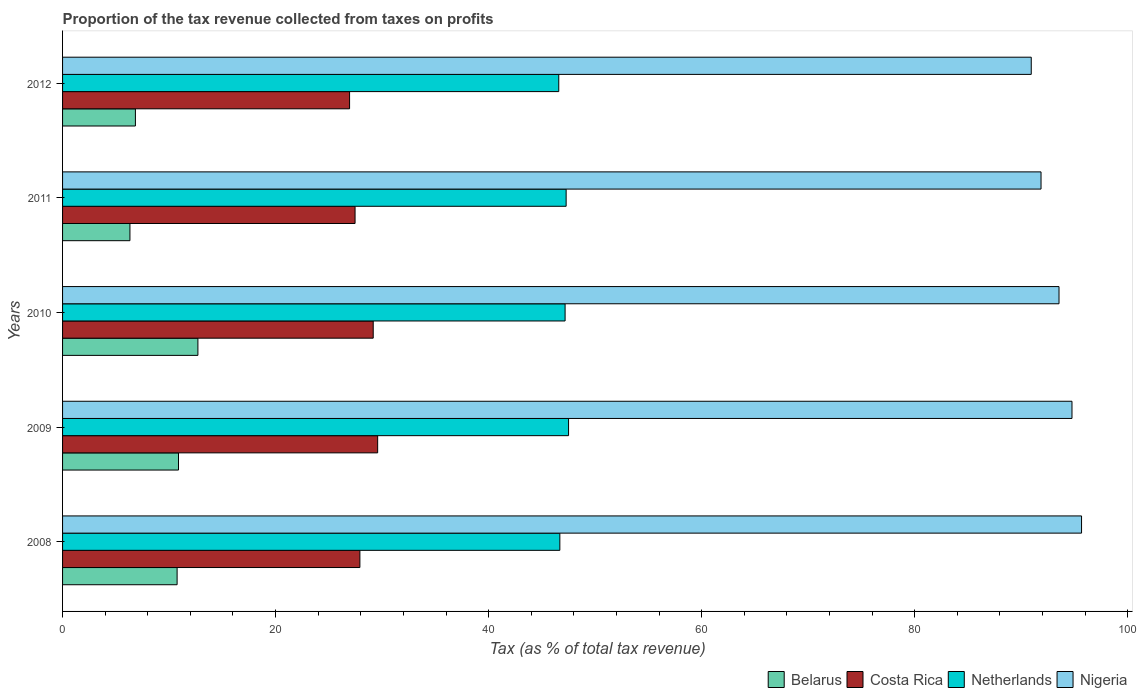Are the number of bars on each tick of the Y-axis equal?
Offer a terse response. Yes. How many bars are there on the 1st tick from the bottom?
Your answer should be very brief. 4. What is the label of the 4th group of bars from the top?
Ensure brevity in your answer.  2009. What is the proportion of the tax revenue collected in Costa Rica in 2012?
Keep it short and to the point. 26.95. Across all years, what is the maximum proportion of the tax revenue collected in Netherlands?
Ensure brevity in your answer.  47.51. Across all years, what is the minimum proportion of the tax revenue collected in Netherlands?
Offer a very short reply. 46.59. What is the total proportion of the tax revenue collected in Belarus in the graph?
Your response must be concise. 47.51. What is the difference between the proportion of the tax revenue collected in Netherlands in 2010 and that in 2011?
Offer a terse response. -0.1. What is the difference between the proportion of the tax revenue collected in Nigeria in 2010 and the proportion of the tax revenue collected in Netherlands in 2012?
Your answer should be compact. 46.97. What is the average proportion of the tax revenue collected in Costa Rica per year?
Your answer should be very brief. 28.21. In the year 2010, what is the difference between the proportion of the tax revenue collected in Belarus and proportion of the tax revenue collected in Nigeria?
Provide a short and direct response. -80.85. In how many years, is the proportion of the tax revenue collected in Belarus greater than 4 %?
Provide a succinct answer. 5. What is the ratio of the proportion of the tax revenue collected in Belarus in 2009 to that in 2011?
Your response must be concise. 1.72. Is the proportion of the tax revenue collected in Belarus in 2009 less than that in 2011?
Your response must be concise. No. What is the difference between the highest and the second highest proportion of the tax revenue collected in Belarus?
Provide a succinct answer. 1.82. What is the difference between the highest and the lowest proportion of the tax revenue collected in Costa Rica?
Keep it short and to the point. 2.64. Is the sum of the proportion of the tax revenue collected in Nigeria in 2011 and 2012 greater than the maximum proportion of the tax revenue collected in Belarus across all years?
Your answer should be very brief. Yes. Is it the case that in every year, the sum of the proportion of the tax revenue collected in Netherlands and proportion of the tax revenue collected in Costa Rica is greater than the sum of proportion of the tax revenue collected in Nigeria and proportion of the tax revenue collected in Belarus?
Give a very brief answer. No. What does the 2nd bar from the bottom in 2008 represents?
Your answer should be compact. Costa Rica. Is it the case that in every year, the sum of the proportion of the tax revenue collected in Netherlands and proportion of the tax revenue collected in Nigeria is greater than the proportion of the tax revenue collected in Costa Rica?
Ensure brevity in your answer.  Yes. Are all the bars in the graph horizontal?
Your answer should be very brief. Yes. How many years are there in the graph?
Your answer should be very brief. 5. Are the values on the major ticks of X-axis written in scientific E-notation?
Make the answer very short. No. How many legend labels are there?
Offer a terse response. 4. What is the title of the graph?
Offer a very short reply. Proportion of the tax revenue collected from taxes on profits. Does "Timor-Leste" appear as one of the legend labels in the graph?
Provide a short and direct response. No. What is the label or title of the X-axis?
Provide a short and direct response. Tax (as % of total tax revenue). What is the Tax (as % of total tax revenue) in Belarus in 2008?
Your answer should be very brief. 10.75. What is the Tax (as % of total tax revenue) of Costa Rica in 2008?
Make the answer very short. 27.91. What is the Tax (as % of total tax revenue) of Netherlands in 2008?
Your answer should be compact. 46.69. What is the Tax (as % of total tax revenue) in Nigeria in 2008?
Keep it short and to the point. 95.67. What is the Tax (as % of total tax revenue) in Belarus in 2009?
Provide a short and direct response. 10.89. What is the Tax (as % of total tax revenue) in Costa Rica in 2009?
Offer a terse response. 29.58. What is the Tax (as % of total tax revenue) of Netherlands in 2009?
Provide a succinct answer. 47.51. What is the Tax (as % of total tax revenue) in Nigeria in 2009?
Offer a very short reply. 94.77. What is the Tax (as % of total tax revenue) of Belarus in 2010?
Your response must be concise. 12.71. What is the Tax (as % of total tax revenue) of Costa Rica in 2010?
Make the answer very short. 29.17. What is the Tax (as % of total tax revenue) in Netherlands in 2010?
Your response must be concise. 47.18. What is the Tax (as % of total tax revenue) of Nigeria in 2010?
Your answer should be very brief. 93.55. What is the Tax (as % of total tax revenue) of Belarus in 2011?
Offer a terse response. 6.32. What is the Tax (as % of total tax revenue) of Costa Rica in 2011?
Make the answer very short. 27.46. What is the Tax (as % of total tax revenue) in Netherlands in 2011?
Ensure brevity in your answer.  47.28. What is the Tax (as % of total tax revenue) in Nigeria in 2011?
Ensure brevity in your answer.  91.87. What is the Tax (as % of total tax revenue) of Belarus in 2012?
Give a very brief answer. 6.84. What is the Tax (as % of total tax revenue) of Costa Rica in 2012?
Keep it short and to the point. 26.95. What is the Tax (as % of total tax revenue) of Netherlands in 2012?
Make the answer very short. 46.59. What is the Tax (as % of total tax revenue) of Nigeria in 2012?
Make the answer very short. 90.95. Across all years, what is the maximum Tax (as % of total tax revenue) in Belarus?
Offer a very short reply. 12.71. Across all years, what is the maximum Tax (as % of total tax revenue) in Costa Rica?
Provide a succinct answer. 29.58. Across all years, what is the maximum Tax (as % of total tax revenue) in Netherlands?
Offer a very short reply. 47.51. Across all years, what is the maximum Tax (as % of total tax revenue) of Nigeria?
Provide a succinct answer. 95.67. Across all years, what is the minimum Tax (as % of total tax revenue) of Belarus?
Give a very brief answer. 6.32. Across all years, what is the minimum Tax (as % of total tax revenue) of Costa Rica?
Your response must be concise. 26.95. Across all years, what is the minimum Tax (as % of total tax revenue) of Netherlands?
Provide a short and direct response. 46.59. Across all years, what is the minimum Tax (as % of total tax revenue) in Nigeria?
Keep it short and to the point. 90.95. What is the total Tax (as % of total tax revenue) in Belarus in the graph?
Offer a terse response. 47.51. What is the total Tax (as % of total tax revenue) in Costa Rica in the graph?
Offer a terse response. 141.07. What is the total Tax (as % of total tax revenue) of Netherlands in the graph?
Provide a succinct answer. 235.25. What is the total Tax (as % of total tax revenue) of Nigeria in the graph?
Offer a terse response. 466.81. What is the difference between the Tax (as % of total tax revenue) of Belarus in 2008 and that in 2009?
Make the answer very short. -0.13. What is the difference between the Tax (as % of total tax revenue) in Costa Rica in 2008 and that in 2009?
Your answer should be very brief. -1.67. What is the difference between the Tax (as % of total tax revenue) of Netherlands in 2008 and that in 2009?
Your answer should be compact. -0.82. What is the difference between the Tax (as % of total tax revenue) in Nigeria in 2008 and that in 2009?
Provide a short and direct response. 0.9. What is the difference between the Tax (as % of total tax revenue) of Belarus in 2008 and that in 2010?
Give a very brief answer. -1.95. What is the difference between the Tax (as % of total tax revenue) in Costa Rica in 2008 and that in 2010?
Offer a terse response. -1.25. What is the difference between the Tax (as % of total tax revenue) of Netherlands in 2008 and that in 2010?
Make the answer very short. -0.49. What is the difference between the Tax (as % of total tax revenue) of Nigeria in 2008 and that in 2010?
Your answer should be very brief. 2.12. What is the difference between the Tax (as % of total tax revenue) in Belarus in 2008 and that in 2011?
Make the answer very short. 4.43. What is the difference between the Tax (as % of total tax revenue) of Costa Rica in 2008 and that in 2011?
Your response must be concise. 0.45. What is the difference between the Tax (as % of total tax revenue) in Netherlands in 2008 and that in 2011?
Ensure brevity in your answer.  -0.59. What is the difference between the Tax (as % of total tax revenue) of Nigeria in 2008 and that in 2011?
Give a very brief answer. 3.8. What is the difference between the Tax (as % of total tax revenue) of Belarus in 2008 and that in 2012?
Ensure brevity in your answer.  3.91. What is the difference between the Tax (as % of total tax revenue) in Costa Rica in 2008 and that in 2012?
Offer a terse response. 0.97. What is the difference between the Tax (as % of total tax revenue) in Netherlands in 2008 and that in 2012?
Ensure brevity in your answer.  0.1. What is the difference between the Tax (as % of total tax revenue) of Nigeria in 2008 and that in 2012?
Provide a succinct answer. 4.72. What is the difference between the Tax (as % of total tax revenue) of Belarus in 2009 and that in 2010?
Your answer should be compact. -1.82. What is the difference between the Tax (as % of total tax revenue) in Costa Rica in 2009 and that in 2010?
Make the answer very short. 0.42. What is the difference between the Tax (as % of total tax revenue) of Netherlands in 2009 and that in 2010?
Offer a terse response. 0.33. What is the difference between the Tax (as % of total tax revenue) of Nigeria in 2009 and that in 2010?
Provide a short and direct response. 1.22. What is the difference between the Tax (as % of total tax revenue) of Belarus in 2009 and that in 2011?
Offer a terse response. 4.56. What is the difference between the Tax (as % of total tax revenue) of Costa Rica in 2009 and that in 2011?
Offer a very short reply. 2.12. What is the difference between the Tax (as % of total tax revenue) in Netherlands in 2009 and that in 2011?
Provide a succinct answer. 0.23. What is the difference between the Tax (as % of total tax revenue) of Nigeria in 2009 and that in 2011?
Give a very brief answer. 2.91. What is the difference between the Tax (as % of total tax revenue) in Belarus in 2009 and that in 2012?
Keep it short and to the point. 4.05. What is the difference between the Tax (as % of total tax revenue) in Costa Rica in 2009 and that in 2012?
Offer a very short reply. 2.64. What is the difference between the Tax (as % of total tax revenue) in Netherlands in 2009 and that in 2012?
Give a very brief answer. 0.92. What is the difference between the Tax (as % of total tax revenue) in Nigeria in 2009 and that in 2012?
Offer a very short reply. 3.82. What is the difference between the Tax (as % of total tax revenue) of Belarus in 2010 and that in 2011?
Your answer should be compact. 6.38. What is the difference between the Tax (as % of total tax revenue) in Costa Rica in 2010 and that in 2011?
Provide a succinct answer. 1.7. What is the difference between the Tax (as % of total tax revenue) of Netherlands in 2010 and that in 2011?
Your answer should be very brief. -0.1. What is the difference between the Tax (as % of total tax revenue) of Nigeria in 2010 and that in 2011?
Keep it short and to the point. 1.69. What is the difference between the Tax (as % of total tax revenue) of Belarus in 2010 and that in 2012?
Give a very brief answer. 5.87. What is the difference between the Tax (as % of total tax revenue) in Costa Rica in 2010 and that in 2012?
Make the answer very short. 2.22. What is the difference between the Tax (as % of total tax revenue) in Netherlands in 2010 and that in 2012?
Your answer should be compact. 0.59. What is the difference between the Tax (as % of total tax revenue) of Nigeria in 2010 and that in 2012?
Provide a short and direct response. 2.61. What is the difference between the Tax (as % of total tax revenue) in Belarus in 2011 and that in 2012?
Offer a very short reply. -0.51. What is the difference between the Tax (as % of total tax revenue) of Costa Rica in 2011 and that in 2012?
Your answer should be very brief. 0.52. What is the difference between the Tax (as % of total tax revenue) of Netherlands in 2011 and that in 2012?
Keep it short and to the point. 0.69. What is the difference between the Tax (as % of total tax revenue) in Nigeria in 2011 and that in 2012?
Offer a very short reply. 0.92. What is the difference between the Tax (as % of total tax revenue) in Belarus in 2008 and the Tax (as % of total tax revenue) in Costa Rica in 2009?
Offer a very short reply. -18.83. What is the difference between the Tax (as % of total tax revenue) in Belarus in 2008 and the Tax (as % of total tax revenue) in Netherlands in 2009?
Keep it short and to the point. -36.75. What is the difference between the Tax (as % of total tax revenue) in Belarus in 2008 and the Tax (as % of total tax revenue) in Nigeria in 2009?
Ensure brevity in your answer.  -84.02. What is the difference between the Tax (as % of total tax revenue) in Costa Rica in 2008 and the Tax (as % of total tax revenue) in Netherlands in 2009?
Give a very brief answer. -19.59. What is the difference between the Tax (as % of total tax revenue) of Costa Rica in 2008 and the Tax (as % of total tax revenue) of Nigeria in 2009?
Your answer should be very brief. -66.86. What is the difference between the Tax (as % of total tax revenue) of Netherlands in 2008 and the Tax (as % of total tax revenue) of Nigeria in 2009?
Your answer should be very brief. -48.08. What is the difference between the Tax (as % of total tax revenue) in Belarus in 2008 and the Tax (as % of total tax revenue) in Costa Rica in 2010?
Your answer should be very brief. -18.41. What is the difference between the Tax (as % of total tax revenue) in Belarus in 2008 and the Tax (as % of total tax revenue) in Netherlands in 2010?
Provide a succinct answer. -36.43. What is the difference between the Tax (as % of total tax revenue) of Belarus in 2008 and the Tax (as % of total tax revenue) of Nigeria in 2010?
Give a very brief answer. -82.8. What is the difference between the Tax (as % of total tax revenue) in Costa Rica in 2008 and the Tax (as % of total tax revenue) in Netherlands in 2010?
Your response must be concise. -19.27. What is the difference between the Tax (as % of total tax revenue) in Costa Rica in 2008 and the Tax (as % of total tax revenue) in Nigeria in 2010?
Your answer should be very brief. -65.64. What is the difference between the Tax (as % of total tax revenue) of Netherlands in 2008 and the Tax (as % of total tax revenue) of Nigeria in 2010?
Keep it short and to the point. -46.87. What is the difference between the Tax (as % of total tax revenue) of Belarus in 2008 and the Tax (as % of total tax revenue) of Costa Rica in 2011?
Your answer should be very brief. -16.71. What is the difference between the Tax (as % of total tax revenue) of Belarus in 2008 and the Tax (as % of total tax revenue) of Netherlands in 2011?
Give a very brief answer. -36.53. What is the difference between the Tax (as % of total tax revenue) of Belarus in 2008 and the Tax (as % of total tax revenue) of Nigeria in 2011?
Offer a very short reply. -81.11. What is the difference between the Tax (as % of total tax revenue) in Costa Rica in 2008 and the Tax (as % of total tax revenue) in Netherlands in 2011?
Keep it short and to the point. -19.36. What is the difference between the Tax (as % of total tax revenue) of Costa Rica in 2008 and the Tax (as % of total tax revenue) of Nigeria in 2011?
Provide a succinct answer. -63.95. What is the difference between the Tax (as % of total tax revenue) in Netherlands in 2008 and the Tax (as % of total tax revenue) in Nigeria in 2011?
Keep it short and to the point. -45.18. What is the difference between the Tax (as % of total tax revenue) of Belarus in 2008 and the Tax (as % of total tax revenue) of Costa Rica in 2012?
Offer a terse response. -16.19. What is the difference between the Tax (as % of total tax revenue) of Belarus in 2008 and the Tax (as % of total tax revenue) of Netherlands in 2012?
Make the answer very short. -35.83. What is the difference between the Tax (as % of total tax revenue) of Belarus in 2008 and the Tax (as % of total tax revenue) of Nigeria in 2012?
Your answer should be very brief. -80.19. What is the difference between the Tax (as % of total tax revenue) of Costa Rica in 2008 and the Tax (as % of total tax revenue) of Netherlands in 2012?
Your answer should be compact. -18.67. What is the difference between the Tax (as % of total tax revenue) of Costa Rica in 2008 and the Tax (as % of total tax revenue) of Nigeria in 2012?
Your answer should be very brief. -63.03. What is the difference between the Tax (as % of total tax revenue) in Netherlands in 2008 and the Tax (as % of total tax revenue) in Nigeria in 2012?
Your answer should be very brief. -44.26. What is the difference between the Tax (as % of total tax revenue) in Belarus in 2009 and the Tax (as % of total tax revenue) in Costa Rica in 2010?
Provide a short and direct response. -18.28. What is the difference between the Tax (as % of total tax revenue) in Belarus in 2009 and the Tax (as % of total tax revenue) in Netherlands in 2010?
Ensure brevity in your answer.  -36.3. What is the difference between the Tax (as % of total tax revenue) in Belarus in 2009 and the Tax (as % of total tax revenue) in Nigeria in 2010?
Provide a succinct answer. -82.67. What is the difference between the Tax (as % of total tax revenue) of Costa Rica in 2009 and the Tax (as % of total tax revenue) of Netherlands in 2010?
Provide a succinct answer. -17.6. What is the difference between the Tax (as % of total tax revenue) in Costa Rica in 2009 and the Tax (as % of total tax revenue) in Nigeria in 2010?
Provide a short and direct response. -63.97. What is the difference between the Tax (as % of total tax revenue) in Netherlands in 2009 and the Tax (as % of total tax revenue) in Nigeria in 2010?
Your response must be concise. -46.05. What is the difference between the Tax (as % of total tax revenue) of Belarus in 2009 and the Tax (as % of total tax revenue) of Costa Rica in 2011?
Offer a terse response. -16.58. What is the difference between the Tax (as % of total tax revenue) in Belarus in 2009 and the Tax (as % of total tax revenue) in Netherlands in 2011?
Your answer should be compact. -36.39. What is the difference between the Tax (as % of total tax revenue) in Belarus in 2009 and the Tax (as % of total tax revenue) in Nigeria in 2011?
Your response must be concise. -80.98. What is the difference between the Tax (as % of total tax revenue) in Costa Rica in 2009 and the Tax (as % of total tax revenue) in Netherlands in 2011?
Ensure brevity in your answer.  -17.7. What is the difference between the Tax (as % of total tax revenue) of Costa Rica in 2009 and the Tax (as % of total tax revenue) of Nigeria in 2011?
Offer a terse response. -62.28. What is the difference between the Tax (as % of total tax revenue) of Netherlands in 2009 and the Tax (as % of total tax revenue) of Nigeria in 2011?
Your answer should be very brief. -44.36. What is the difference between the Tax (as % of total tax revenue) in Belarus in 2009 and the Tax (as % of total tax revenue) in Costa Rica in 2012?
Your answer should be very brief. -16.06. What is the difference between the Tax (as % of total tax revenue) of Belarus in 2009 and the Tax (as % of total tax revenue) of Netherlands in 2012?
Make the answer very short. -35.7. What is the difference between the Tax (as % of total tax revenue) of Belarus in 2009 and the Tax (as % of total tax revenue) of Nigeria in 2012?
Your response must be concise. -80.06. What is the difference between the Tax (as % of total tax revenue) of Costa Rica in 2009 and the Tax (as % of total tax revenue) of Netherlands in 2012?
Offer a terse response. -17. What is the difference between the Tax (as % of total tax revenue) of Costa Rica in 2009 and the Tax (as % of total tax revenue) of Nigeria in 2012?
Your answer should be compact. -61.37. What is the difference between the Tax (as % of total tax revenue) in Netherlands in 2009 and the Tax (as % of total tax revenue) in Nigeria in 2012?
Your answer should be compact. -43.44. What is the difference between the Tax (as % of total tax revenue) of Belarus in 2010 and the Tax (as % of total tax revenue) of Costa Rica in 2011?
Your response must be concise. -14.76. What is the difference between the Tax (as % of total tax revenue) of Belarus in 2010 and the Tax (as % of total tax revenue) of Netherlands in 2011?
Your answer should be compact. -34.57. What is the difference between the Tax (as % of total tax revenue) of Belarus in 2010 and the Tax (as % of total tax revenue) of Nigeria in 2011?
Your answer should be very brief. -79.16. What is the difference between the Tax (as % of total tax revenue) of Costa Rica in 2010 and the Tax (as % of total tax revenue) of Netherlands in 2011?
Your response must be concise. -18.11. What is the difference between the Tax (as % of total tax revenue) in Costa Rica in 2010 and the Tax (as % of total tax revenue) in Nigeria in 2011?
Offer a very short reply. -62.7. What is the difference between the Tax (as % of total tax revenue) of Netherlands in 2010 and the Tax (as % of total tax revenue) of Nigeria in 2011?
Keep it short and to the point. -44.68. What is the difference between the Tax (as % of total tax revenue) of Belarus in 2010 and the Tax (as % of total tax revenue) of Costa Rica in 2012?
Your answer should be compact. -14.24. What is the difference between the Tax (as % of total tax revenue) in Belarus in 2010 and the Tax (as % of total tax revenue) in Netherlands in 2012?
Your answer should be very brief. -33.88. What is the difference between the Tax (as % of total tax revenue) in Belarus in 2010 and the Tax (as % of total tax revenue) in Nigeria in 2012?
Provide a succinct answer. -78.24. What is the difference between the Tax (as % of total tax revenue) of Costa Rica in 2010 and the Tax (as % of total tax revenue) of Netherlands in 2012?
Your answer should be very brief. -17.42. What is the difference between the Tax (as % of total tax revenue) of Costa Rica in 2010 and the Tax (as % of total tax revenue) of Nigeria in 2012?
Provide a short and direct response. -61.78. What is the difference between the Tax (as % of total tax revenue) in Netherlands in 2010 and the Tax (as % of total tax revenue) in Nigeria in 2012?
Make the answer very short. -43.77. What is the difference between the Tax (as % of total tax revenue) in Belarus in 2011 and the Tax (as % of total tax revenue) in Costa Rica in 2012?
Make the answer very short. -20.62. What is the difference between the Tax (as % of total tax revenue) in Belarus in 2011 and the Tax (as % of total tax revenue) in Netherlands in 2012?
Provide a short and direct response. -40.26. What is the difference between the Tax (as % of total tax revenue) of Belarus in 2011 and the Tax (as % of total tax revenue) of Nigeria in 2012?
Offer a terse response. -84.62. What is the difference between the Tax (as % of total tax revenue) of Costa Rica in 2011 and the Tax (as % of total tax revenue) of Netherlands in 2012?
Your response must be concise. -19.13. What is the difference between the Tax (as % of total tax revenue) of Costa Rica in 2011 and the Tax (as % of total tax revenue) of Nigeria in 2012?
Provide a succinct answer. -63.49. What is the difference between the Tax (as % of total tax revenue) of Netherlands in 2011 and the Tax (as % of total tax revenue) of Nigeria in 2012?
Make the answer very short. -43.67. What is the average Tax (as % of total tax revenue) in Belarus per year?
Keep it short and to the point. 9.5. What is the average Tax (as % of total tax revenue) in Costa Rica per year?
Offer a very short reply. 28.21. What is the average Tax (as % of total tax revenue) in Netherlands per year?
Keep it short and to the point. 47.05. What is the average Tax (as % of total tax revenue) in Nigeria per year?
Your response must be concise. 93.36. In the year 2008, what is the difference between the Tax (as % of total tax revenue) of Belarus and Tax (as % of total tax revenue) of Costa Rica?
Give a very brief answer. -17.16. In the year 2008, what is the difference between the Tax (as % of total tax revenue) in Belarus and Tax (as % of total tax revenue) in Netherlands?
Your response must be concise. -35.93. In the year 2008, what is the difference between the Tax (as % of total tax revenue) of Belarus and Tax (as % of total tax revenue) of Nigeria?
Your answer should be compact. -84.92. In the year 2008, what is the difference between the Tax (as % of total tax revenue) in Costa Rica and Tax (as % of total tax revenue) in Netherlands?
Your response must be concise. -18.77. In the year 2008, what is the difference between the Tax (as % of total tax revenue) of Costa Rica and Tax (as % of total tax revenue) of Nigeria?
Make the answer very short. -67.76. In the year 2008, what is the difference between the Tax (as % of total tax revenue) of Netherlands and Tax (as % of total tax revenue) of Nigeria?
Your answer should be compact. -48.98. In the year 2009, what is the difference between the Tax (as % of total tax revenue) in Belarus and Tax (as % of total tax revenue) in Costa Rica?
Provide a succinct answer. -18.7. In the year 2009, what is the difference between the Tax (as % of total tax revenue) of Belarus and Tax (as % of total tax revenue) of Netherlands?
Make the answer very short. -36.62. In the year 2009, what is the difference between the Tax (as % of total tax revenue) in Belarus and Tax (as % of total tax revenue) in Nigeria?
Your answer should be compact. -83.89. In the year 2009, what is the difference between the Tax (as % of total tax revenue) in Costa Rica and Tax (as % of total tax revenue) in Netherlands?
Keep it short and to the point. -17.92. In the year 2009, what is the difference between the Tax (as % of total tax revenue) in Costa Rica and Tax (as % of total tax revenue) in Nigeria?
Your answer should be very brief. -65.19. In the year 2009, what is the difference between the Tax (as % of total tax revenue) of Netherlands and Tax (as % of total tax revenue) of Nigeria?
Your answer should be very brief. -47.26. In the year 2010, what is the difference between the Tax (as % of total tax revenue) of Belarus and Tax (as % of total tax revenue) of Costa Rica?
Your answer should be very brief. -16.46. In the year 2010, what is the difference between the Tax (as % of total tax revenue) in Belarus and Tax (as % of total tax revenue) in Netherlands?
Ensure brevity in your answer.  -34.48. In the year 2010, what is the difference between the Tax (as % of total tax revenue) of Belarus and Tax (as % of total tax revenue) of Nigeria?
Your answer should be very brief. -80.85. In the year 2010, what is the difference between the Tax (as % of total tax revenue) in Costa Rica and Tax (as % of total tax revenue) in Netherlands?
Your answer should be compact. -18.02. In the year 2010, what is the difference between the Tax (as % of total tax revenue) of Costa Rica and Tax (as % of total tax revenue) of Nigeria?
Your response must be concise. -64.39. In the year 2010, what is the difference between the Tax (as % of total tax revenue) in Netherlands and Tax (as % of total tax revenue) in Nigeria?
Ensure brevity in your answer.  -46.37. In the year 2011, what is the difference between the Tax (as % of total tax revenue) of Belarus and Tax (as % of total tax revenue) of Costa Rica?
Provide a short and direct response. -21.14. In the year 2011, what is the difference between the Tax (as % of total tax revenue) in Belarus and Tax (as % of total tax revenue) in Netherlands?
Provide a succinct answer. -40.95. In the year 2011, what is the difference between the Tax (as % of total tax revenue) in Belarus and Tax (as % of total tax revenue) in Nigeria?
Your response must be concise. -85.54. In the year 2011, what is the difference between the Tax (as % of total tax revenue) of Costa Rica and Tax (as % of total tax revenue) of Netherlands?
Offer a very short reply. -19.82. In the year 2011, what is the difference between the Tax (as % of total tax revenue) of Costa Rica and Tax (as % of total tax revenue) of Nigeria?
Your response must be concise. -64.4. In the year 2011, what is the difference between the Tax (as % of total tax revenue) in Netherlands and Tax (as % of total tax revenue) in Nigeria?
Offer a very short reply. -44.59. In the year 2012, what is the difference between the Tax (as % of total tax revenue) of Belarus and Tax (as % of total tax revenue) of Costa Rica?
Offer a terse response. -20.11. In the year 2012, what is the difference between the Tax (as % of total tax revenue) of Belarus and Tax (as % of total tax revenue) of Netherlands?
Provide a short and direct response. -39.75. In the year 2012, what is the difference between the Tax (as % of total tax revenue) of Belarus and Tax (as % of total tax revenue) of Nigeria?
Your response must be concise. -84.11. In the year 2012, what is the difference between the Tax (as % of total tax revenue) of Costa Rica and Tax (as % of total tax revenue) of Netherlands?
Provide a succinct answer. -19.64. In the year 2012, what is the difference between the Tax (as % of total tax revenue) in Costa Rica and Tax (as % of total tax revenue) in Nigeria?
Offer a very short reply. -64. In the year 2012, what is the difference between the Tax (as % of total tax revenue) of Netherlands and Tax (as % of total tax revenue) of Nigeria?
Provide a succinct answer. -44.36. What is the ratio of the Tax (as % of total tax revenue) in Belarus in 2008 to that in 2009?
Ensure brevity in your answer.  0.99. What is the ratio of the Tax (as % of total tax revenue) in Costa Rica in 2008 to that in 2009?
Make the answer very short. 0.94. What is the ratio of the Tax (as % of total tax revenue) in Netherlands in 2008 to that in 2009?
Give a very brief answer. 0.98. What is the ratio of the Tax (as % of total tax revenue) in Nigeria in 2008 to that in 2009?
Ensure brevity in your answer.  1.01. What is the ratio of the Tax (as % of total tax revenue) of Belarus in 2008 to that in 2010?
Keep it short and to the point. 0.85. What is the ratio of the Tax (as % of total tax revenue) of Costa Rica in 2008 to that in 2010?
Give a very brief answer. 0.96. What is the ratio of the Tax (as % of total tax revenue) in Nigeria in 2008 to that in 2010?
Keep it short and to the point. 1.02. What is the ratio of the Tax (as % of total tax revenue) of Belarus in 2008 to that in 2011?
Your answer should be compact. 1.7. What is the ratio of the Tax (as % of total tax revenue) of Costa Rica in 2008 to that in 2011?
Make the answer very short. 1.02. What is the ratio of the Tax (as % of total tax revenue) of Netherlands in 2008 to that in 2011?
Provide a succinct answer. 0.99. What is the ratio of the Tax (as % of total tax revenue) in Nigeria in 2008 to that in 2011?
Ensure brevity in your answer.  1.04. What is the ratio of the Tax (as % of total tax revenue) of Belarus in 2008 to that in 2012?
Your answer should be compact. 1.57. What is the ratio of the Tax (as % of total tax revenue) of Costa Rica in 2008 to that in 2012?
Your answer should be compact. 1.04. What is the ratio of the Tax (as % of total tax revenue) in Nigeria in 2008 to that in 2012?
Your answer should be very brief. 1.05. What is the ratio of the Tax (as % of total tax revenue) of Belarus in 2009 to that in 2010?
Offer a terse response. 0.86. What is the ratio of the Tax (as % of total tax revenue) of Costa Rica in 2009 to that in 2010?
Offer a terse response. 1.01. What is the ratio of the Tax (as % of total tax revenue) in Belarus in 2009 to that in 2011?
Offer a very short reply. 1.72. What is the ratio of the Tax (as % of total tax revenue) of Costa Rica in 2009 to that in 2011?
Make the answer very short. 1.08. What is the ratio of the Tax (as % of total tax revenue) in Netherlands in 2009 to that in 2011?
Give a very brief answer. 1. What is the ratio of the Tax (as % of total tax revenue) of Nigeria in 2009 to that in 2011?
Offer a terse response. 1.03. What is the ratio of the Tax (as % of total tax revenue) of Belarus in 2009 to that in 2012?
Ensure brevity in your answer.  1.59. What is the ratio of the Tax (as % of total tax revenue) of Costa Rica in 2009 to that in 2012?
Your answer should be very brief. 1.1. What is the ratio of the Tax (as % of total tax revenue) in Netherlands in 2009 to that in 2012?
Your answer should be compact. 1.02. What is the ratio of the Tax (as % of total tax revenue) of Nigeria in 2009 to that in 2012?
Ensure brevity in your answer.  1.04. What is the ratio of the Tax (as % of total tax revenue) of Belarus in 2010 to that in 2011?
Your answer should be compact. 2.01. What is the ratio of the Tax (as % of total tax revenue) in Costa Rica in 2010 to that in 2011?
Offer a terse response. 1.06. What is the ratio of the Tax (as % of total tax revenue) of Nigeria in 2010 to that in 2011?
Provide a short and direct response. 1.02. What is the ratio of the Tax (as % of total tax revenue) in Belarus in 2010 to that in 2012?
Keep it short and to the point. 1.86. What is the ratio of the Tax (as % of total tax revenue) of Costa Rica in 2010 to that in 2012?
Give a very brief answer. 1.08. What is the ratio of the Tax (as % of total tax revenue) in Netherlands in 2010 to that in 2012?
Offer a very short reply. 1.01. What is the ratio of the Tax (as % of total tax revenue) of Nigeria in 2010 to that in 2012?
Give a very brief answer. 1.03. What is the ratio of the Tax (as % of total tax revenue) in Belarus in 2011 to that in 2012?
Offer a terse response. 0.92. What is the ratio of the Tax (as % of total tax revenue) in Costa Rica in 2011 to that in 2012?
Give a very brief answer. 1.02. What is the ratio of the Tax (as % of total tax revenue) in Netherlands in 2011 to that in 2012?
Provide a short and direct response. 1.01. What is the ratio of the Tax (as % of total tax revenue) in Nigeria in 2011 to that in 2012?
Provide a short and direct response. 1.01. What is the difference between the highest and the second highest Tax (as % of total tax revenue) of Belarus?
Offer a very short reply. 1.82. What is the difference between the highest and the second highest Tax (as % of total tax revenue) of Costa Rica?
Your answer should be very brief. 0.42. What is the difference between the highest and the second highest Tax (as % of total tax revenue) in Netherlands?
Offer a very short reply. 0.23. What is the difference between the highest and the second highest Tax (as % of total tax revenue) in Nigeria?
Your response must be concise. 0.9. What is the difference between the highest and the lowest Tax (as % of total tax revenue) in Belarus?
Provide a succinct answer. 6.38. What is the difference between the highest and the lowest Tax (as % of total tax revenue) of Costa Rica?
Ensure brevity in your answer.  2.64. What is the difference between the highest and the lowest Tax (as % of total tax revenue) in Netherlands?
Your answer should be very brief. 0.92. What is the difference between the highest and the lowest Tax (as % of total tax revenue) in Nigeria?
Offer a very short reply. 4.72. 